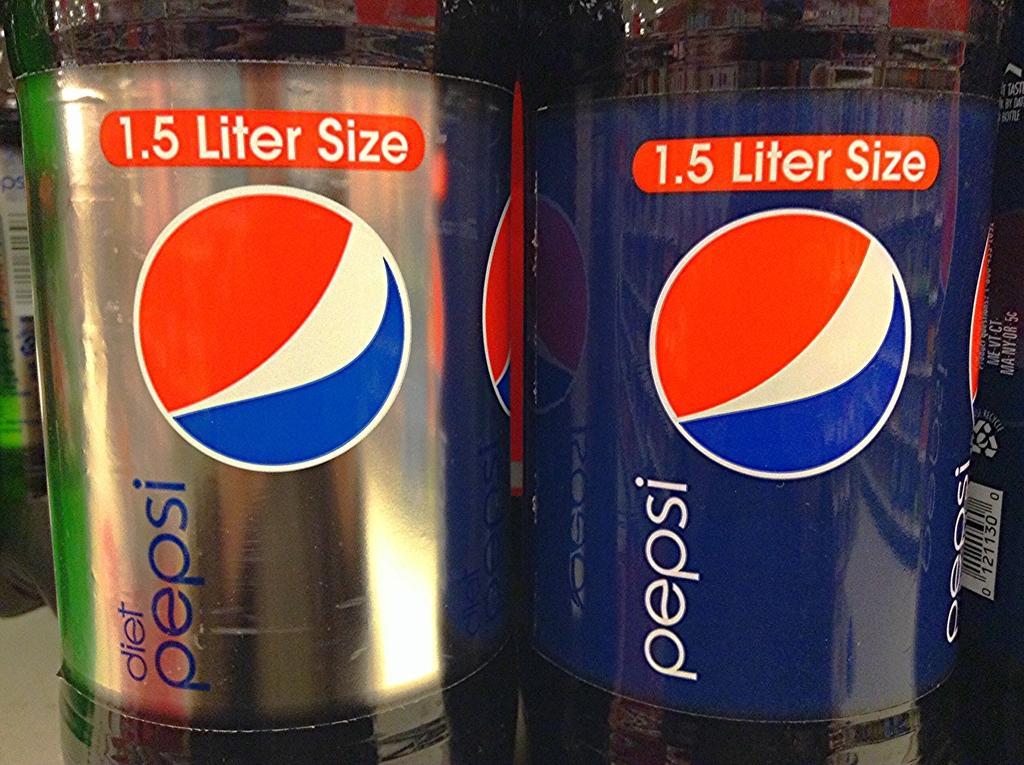How would you summarize this image in a sentence or two? In this picture there are bottles and there are labels on the bottles. On the labels there are logos and there is a text. 